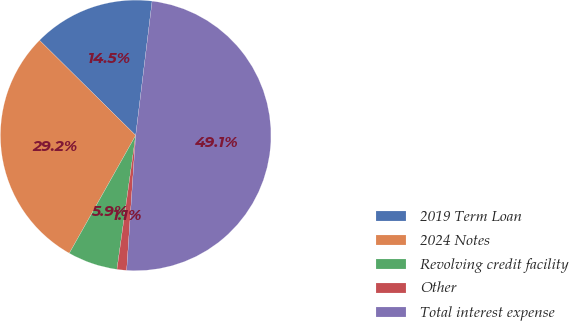Convert chart to OTSL. <chart><loc_0><loc_0><loc_500><loc_500><pie_chart><fcel>2019 Term Loan<fcel>2024 Notes<fcel>Revolving credit facility<fcel>Other<fcel>Total interest expense<nl><fcel>14.53%<fcel>29.25%<fcel>5.95%<fcel>1.15%<fcel>49.13%<nl></chart> 